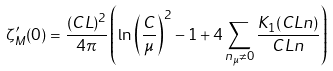Convert formula to latex. <formula><loc_0><loc_0><loc_500><loc_500>\zeta _ { M } ^ { \prime } ( 0 ) = \frac { ( C L ) ^ { 2 } } { 4 \pi } \left ( \ln \left ( \frac { C } { \mu } \right ) ^ { 2 } - 1 + 4 \sum _ { n _ { \mu } \neq 0 } \frac { K _ { 1 } ( C L n ) } { C L n } \right )</formula> 